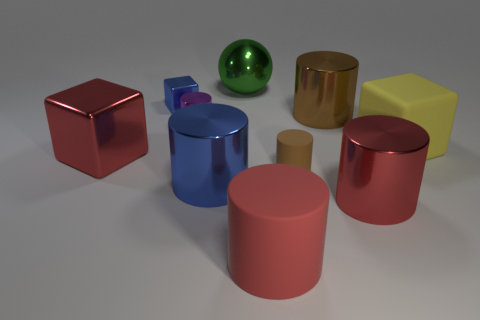Subtract all big red rubber cylinders. How many cylinders are left? 5 Subtract all purple cylinders. How many cylinders are left? 5 Subtract all brown spheres. Subtract all green cylinders. How many spheres are left? 1 Subtract all cyan cylinders. How many blue cubes are left? 1 Subtract all large yellow matte blocks. Subtract all large red rubber things. How many objects are left? 8 Add 4 cylinders. How many cylinders are left? 10 Add 6 small gray rubber cylinders. How many small gray rubber cylinders exist? 6 Subtract 0 yellow cylinders. How many objects are left? 10 Subtract all balls. How many objects are left? 9 